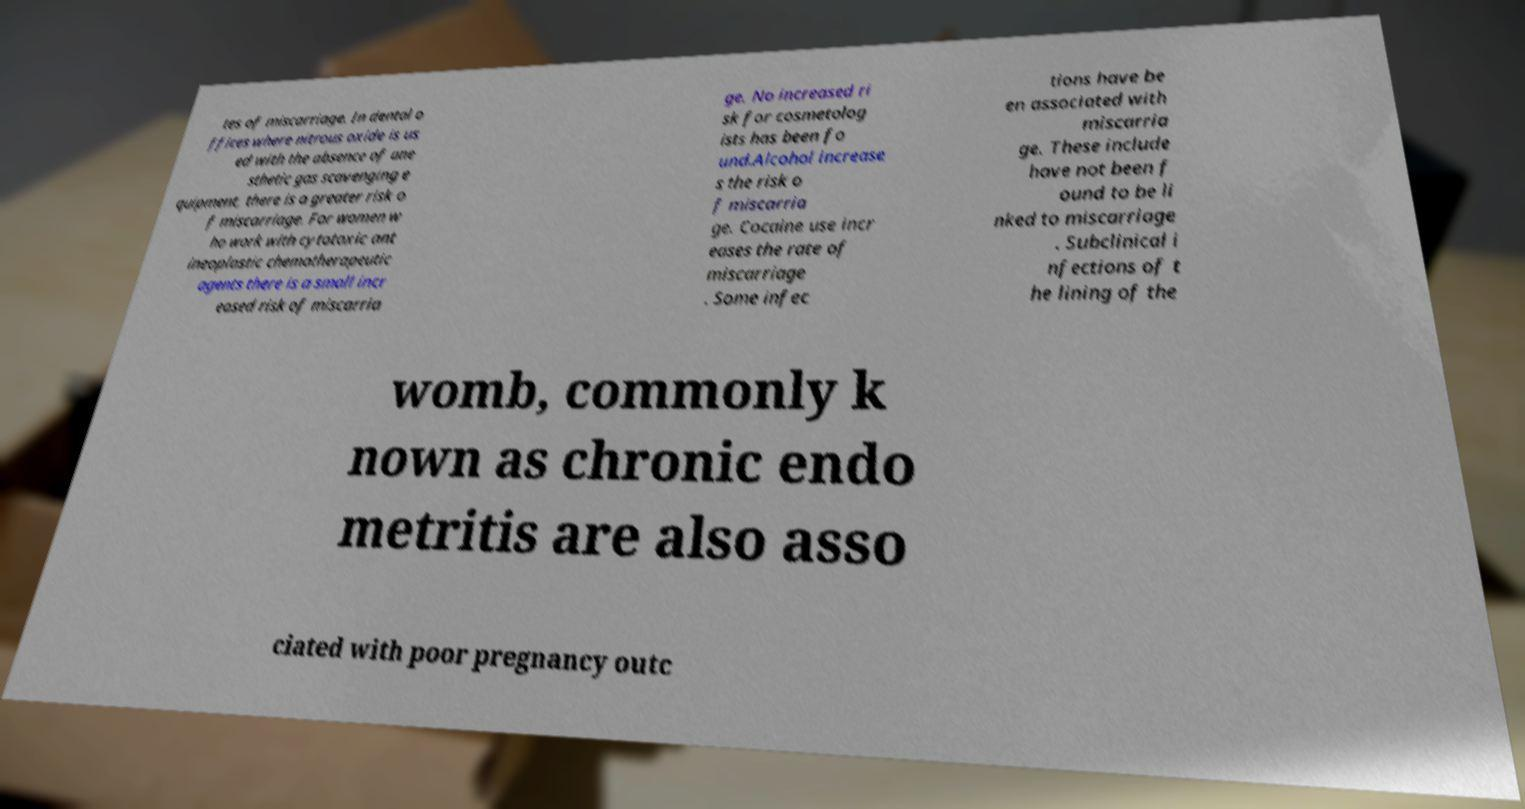For documentation purposes, I need the text within this image transcribed. Could you provide that? tes of miscarriage. In dental o ffices where nitrous oxide is us ed with the absence of ane sthetic gas scavenging e quipment, there is a greater risk o f miscarriage. For women w ho work with cytotoxic ant ineoplastic chemotherapeutic agents there is a small incr eased risk of miscarria ge. No increased ri sk for cosmetolog ists has been fo und.Alcohol increase s the risk o f miscarria ge. Cocaine use incr eases the rate of miscarriage . Some infec tions have be en associated with miscarria ge. These include have not been f ound to be li nked to miscarriage . Subclinical i nfections of t he lining of the womb, commonly k nown as chronic endo metritis are also asso ciated with poor pregnancy outc 